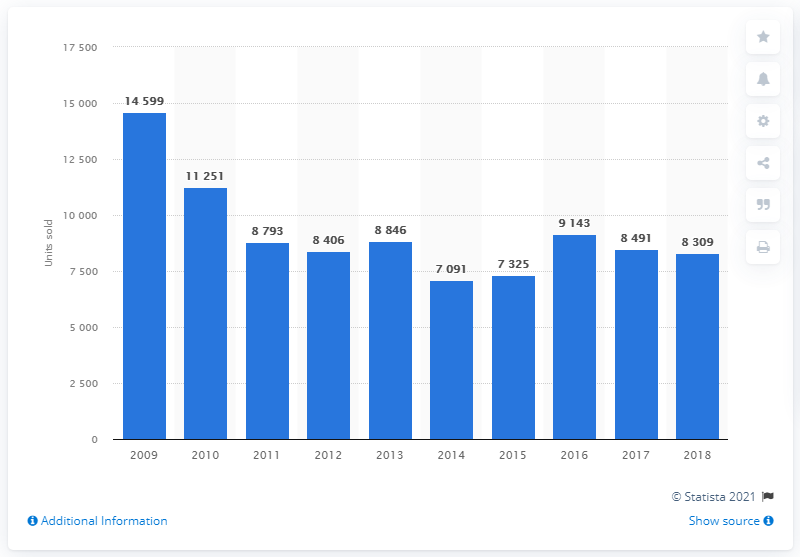Point out several critical features in this image. In 2018, a total of 8,309 Honda cars were sold in France. 